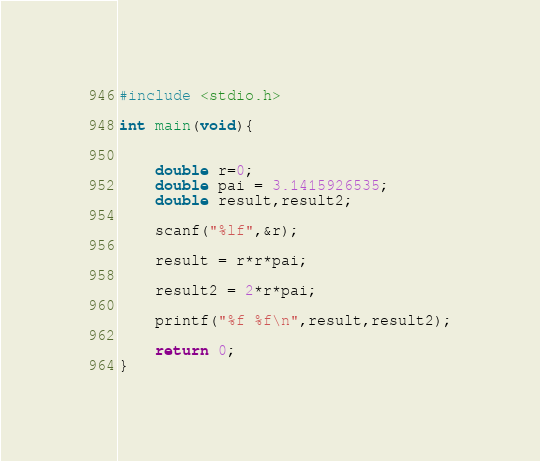Convert code to text. <code><loc_0><loc_0><loc_500><loc_500><_C_>
#include <stdio.h>

int main(void){
    

    double r=0;
    double pai = 3.1415926535;
    double result,result2;
    
    scanf("%lf",&r);
    
    result = r*r*pai;
    
    result2 = 2*r*pai;
    
    printf("%f %f\n",result,result2);
    
    return 0;
}</code> 